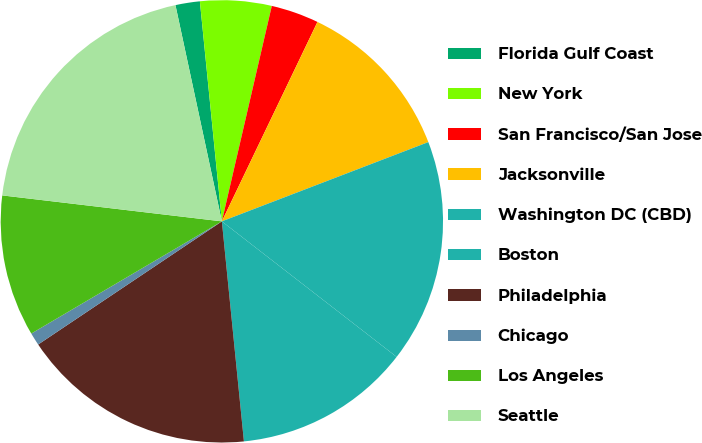<chart> <loc_0><loc_0><loc_500><loc_500><pie_chart><fcel>Florida Gulf Coast<fcel>New York<fcel>San Francisco/San Jose<fcel>Jacksonville<fcel>Washington DC (CBD)<fcel>Boston<fcel>Philadelphia<fcel>Chicago<fcel>Los Angeles<fcel>Seattle<nl><fcel>1.78%<fcel>5.21%<fcel>3.49%<fcel>12.05%<fcel>16.33%<fcel>12.91%<fcel>17.19%<fcel>0.93%<fcel>10.34%<fcel>19.76%<nl></chart> 